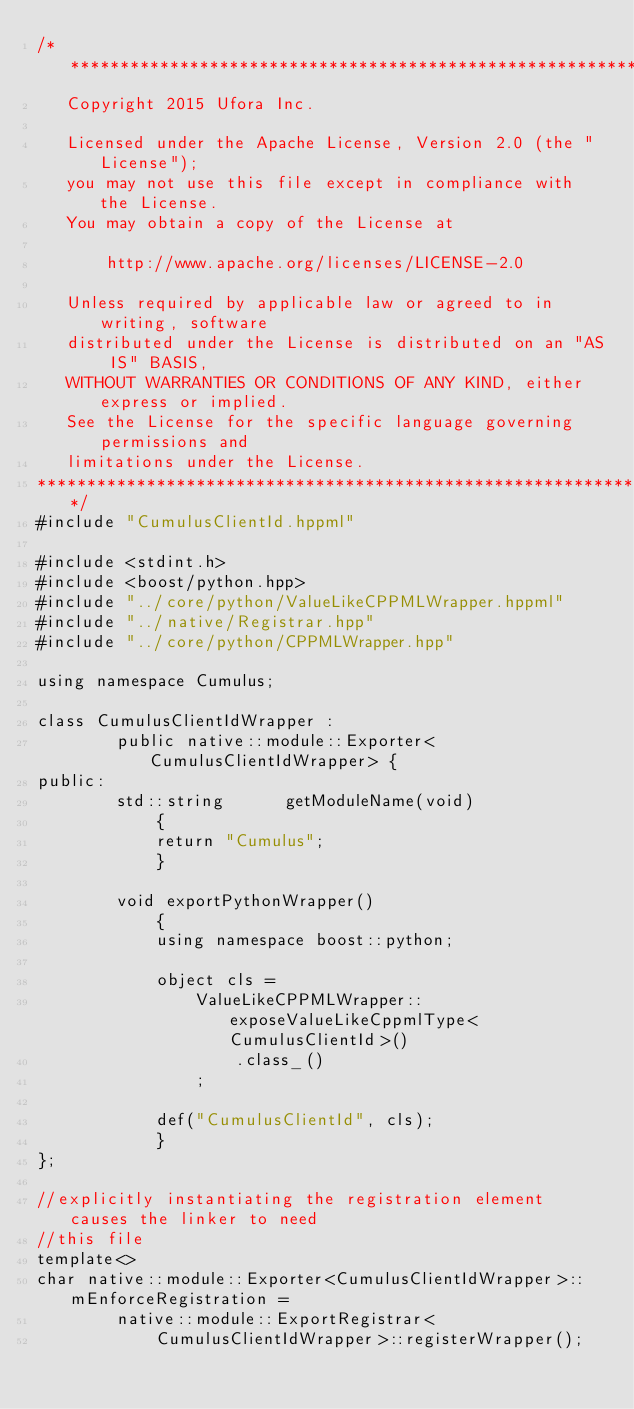<code> <loc_0><loc_0><loc_500><loc_500><_C++_>/***************************************************************************
   Copyright 2015 Ufora Inc.

   Licensed under the Apache License, Version 2.0 (the "License");
   you may not use this file except in compliance with the License.
   You may obtain a copy of the License at

       http://www.apache.org/licenses/LICENSE-2.0

   Unless required by applicable law or agreed to in writing, software
   distributed under the License is distributed on an "AS IS" BASIS,
   WITHOUT WARRANTIES OR CONDITIONS OF ANY KIND, either express or implied.
   See the License for the specific language governing permissions and
   limitations under the License.
****************************************************************************/
#include "CumulusClientId.hppml"

#include <stdint.h>
#include <boost/python.hpp>
#include "../core/python/ValueLikeCPPMLWrapper.hppml"
#include "../native/Registrar.hpp"
#include "../core/python/CPPMLWrapper.hpp"

using namespace Cumulus;

class CumulusClientIdWrapper :
		public native::module::Exporter<CumulusClientIdWrapper> {
public:
		std::string	     getModuleName(void)
			{
			return "Cumulus";
			}

		void exportPythonWrapper()
			{
			using namespace boost::python;

			object cls =
				ValueLikeCPPMLWrapper::exposeValueLikeCppmlType<CumulusClientId>()
					.class_()
				;

			def("CumulusClientId", cls);
			}
};

//explicitly instantiating the registration element causes the linker to need
//this file
template<>
char native::module::Exporter<CumulusClientIdWrapper>::mEnforceRegistration =
		native::module::ExportRegistrar<
			CumulusClientIdWrapper>::registerWrapper();




</code> 